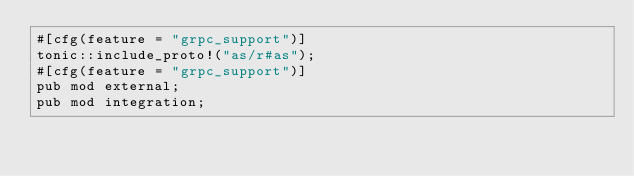Convert code to text. <code><loc_0><loc_0><loc_500><loc_500><_Rust_>#[cfg(feature = "grpc_support")]
tonic::include_proto!("as/r#as");
#[cfg(feature = "grpc_support")]
pub mod external;
pub mod integration;
</code> 